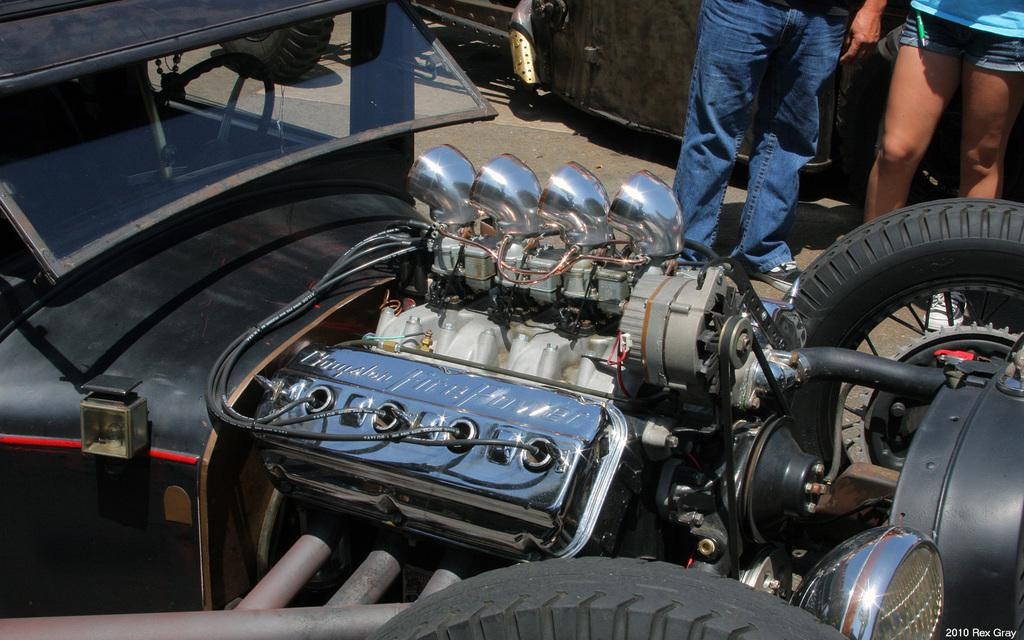What is the main subject of the image? The main subject of the image is the motor of a vehicle. Are there any people present in the image? Yes, there are two persons standing in the background of the image. Where are the persons standing? The persons are standing on the floor. What type of skin condition can be seen on the motor in the image? There is no skin condition present on the motor in the image, as it is a mechanical object and not a living organism. 